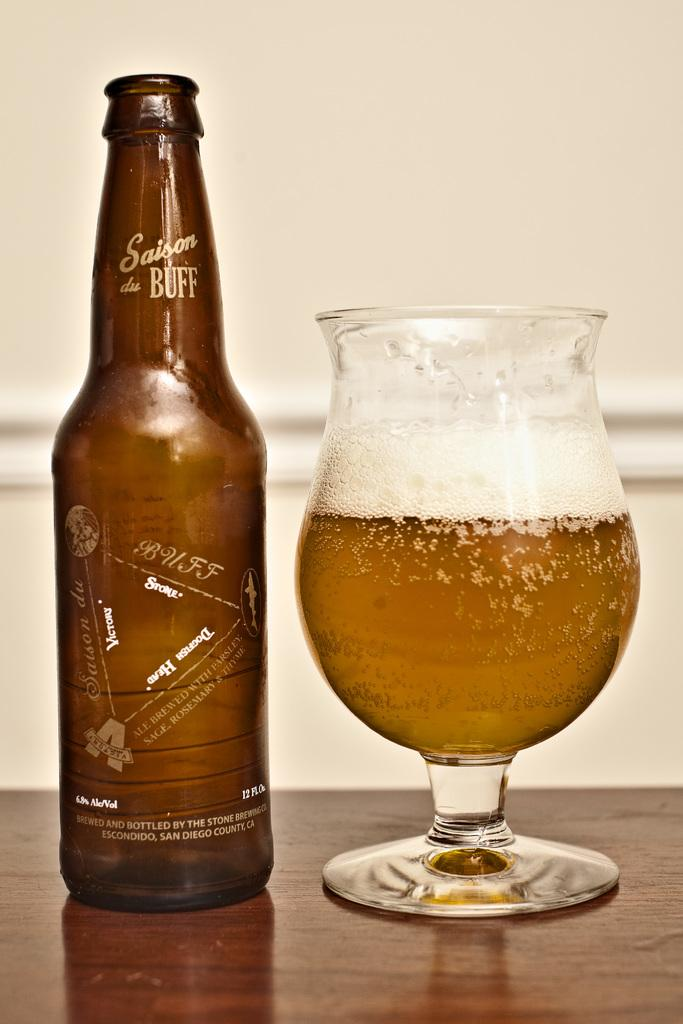Provide a one-sentence caption for the provided image. A bottle of Saison du Buff next to a full glass. 